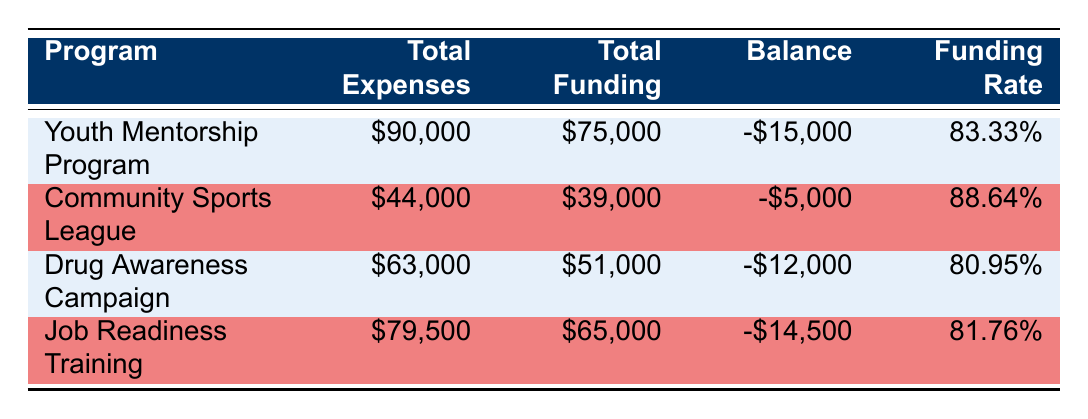What is the total expense for the Youth Mentorship Program? The total expenses for the Youth Mentorship Program are listed in the table as 90,000.
Answer: 90,000 Which program has the highest total balance? To find the highest total balance, we need to compare the balances for each program. The balances are -15,000, -5,000, -12,000, and -14,500. The Community Sports League has the least negative balance of -5,000, which means it has the highest total balance compared to the others.
Answer: Community Sports League What are the combined total expenses for the Drug Awareness Campaign and Job Readiness Training? The total expenses for the Drug Awareness Campaign are 63,000 and for Job Readiness Training are 79,500. Adding these two amounts gives 63,000 + 79,500 = 142,500.
Answer: 142,500 Is the funding for the Community Sports League more than its total expenses? The funding for the Community Sports League is 39,000 and the total expenses are 44,000. Since 39,000 is less than 44,000, the statement is false.
Answer: No What is the average funding rate of all programs? The funding rates for the programs are 83.33%, 88.64%, 80.95%, and 81.76%. To find the average, we sum these rates: 83.33 + 88.64 + 80.95 + 81.76 = 334.68, and then divide by the number of programs (4): 334.68 / 4 = 83.67.
Answer: 83.67 Which program received the least funding? The funding amounts are 75,000, 39,000, 51,000, and 65,000. The Community Sports League received the least funding at 39,000.
Answer: Community Sports League What is the total discrepancy between funding and expenses across all programs? The discrepancies for each program are -15,000, -5,000, -12,000, and -14,500. We add these values together: -15,000 + -5,000 + -12,000 + -14,500 = -46,500.
Answer: -46,500 Did the Youth Mentorship Program receive more funding than the total expenses of the Community Sports League? The Youth Mentorship Program received 75,000 and the Community Sports League had total expenses of 44,000. Since 75,000 is greater than 44,000, the statement is true.
Answer: Yes 